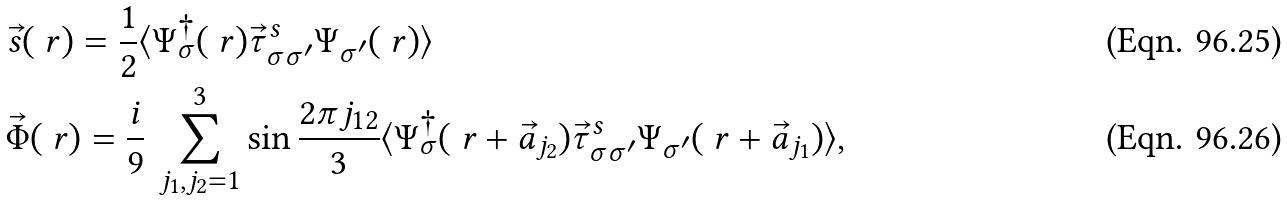Convert formula to latex. <formula><loc_0><loc_0><loc_500><loc_500>& \vec { s } ( \ r ) = \frac { 1 } { 2 } \langle \Psi _ { \sigma } ^ { \dagger } ( \ r ) \vec { \tau } _ { \sigma \sigma ^ { \prime } } ^ { s } \Psi _ { \sigma ^ { \prime } } ( \ r ) \rangle \\ & \vec { \Phi } ( \ r ) = \frac { i } { 9 } \, \sum _ { j _ { 1 } , j _ { 2 } = 1 } ^ { 3 } \sin \frac { 2 \pi j _ { 1 2 } } { 3 } \langle \Psi _ { \sigma } ^ { \dagger } ( \ r + \vec { a } _ { j _ { 2 } } ) \vec { \tau } _ { \sigma \sigma ^ { \prime } } ^ { s } \Psi _ { \sigma ^ { \prime } } ( \ r + \vec { a } _ { j _ { 1 } } ) \rangle ,</formula> 